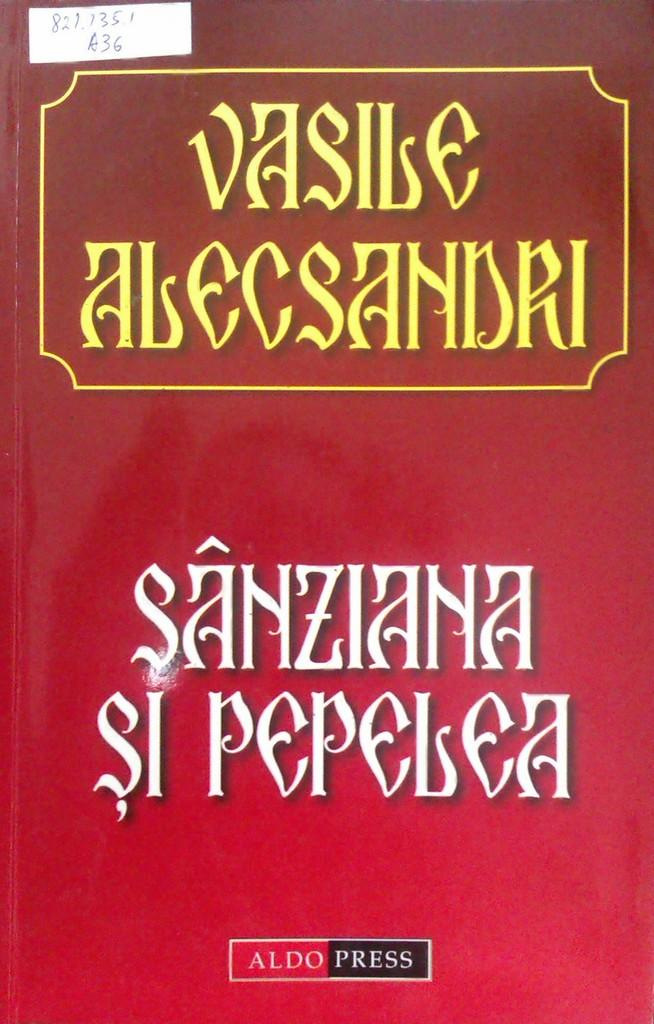<image>
Describe the image concisely. A red book was published by Aldo Press. 